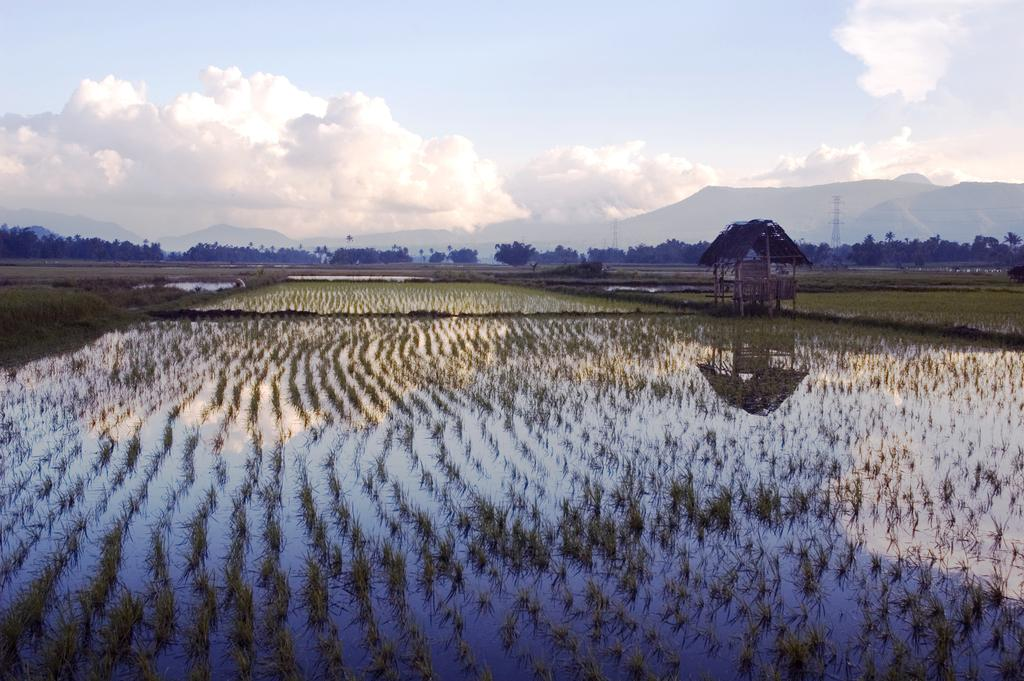What is the primary element visible in the image? There is water in the image. What other objects or features can be seen in the image? There are plants, a hut, trees, hills, towers, and clouds visible in the image. Can you describe the background of the image? The background of the image includes trees, hills, towers, and clouds. What type of disgust can be seen on the faces of the people in the image? There are no people present in the image, so it is not possible to determine their emotions or expressions. 